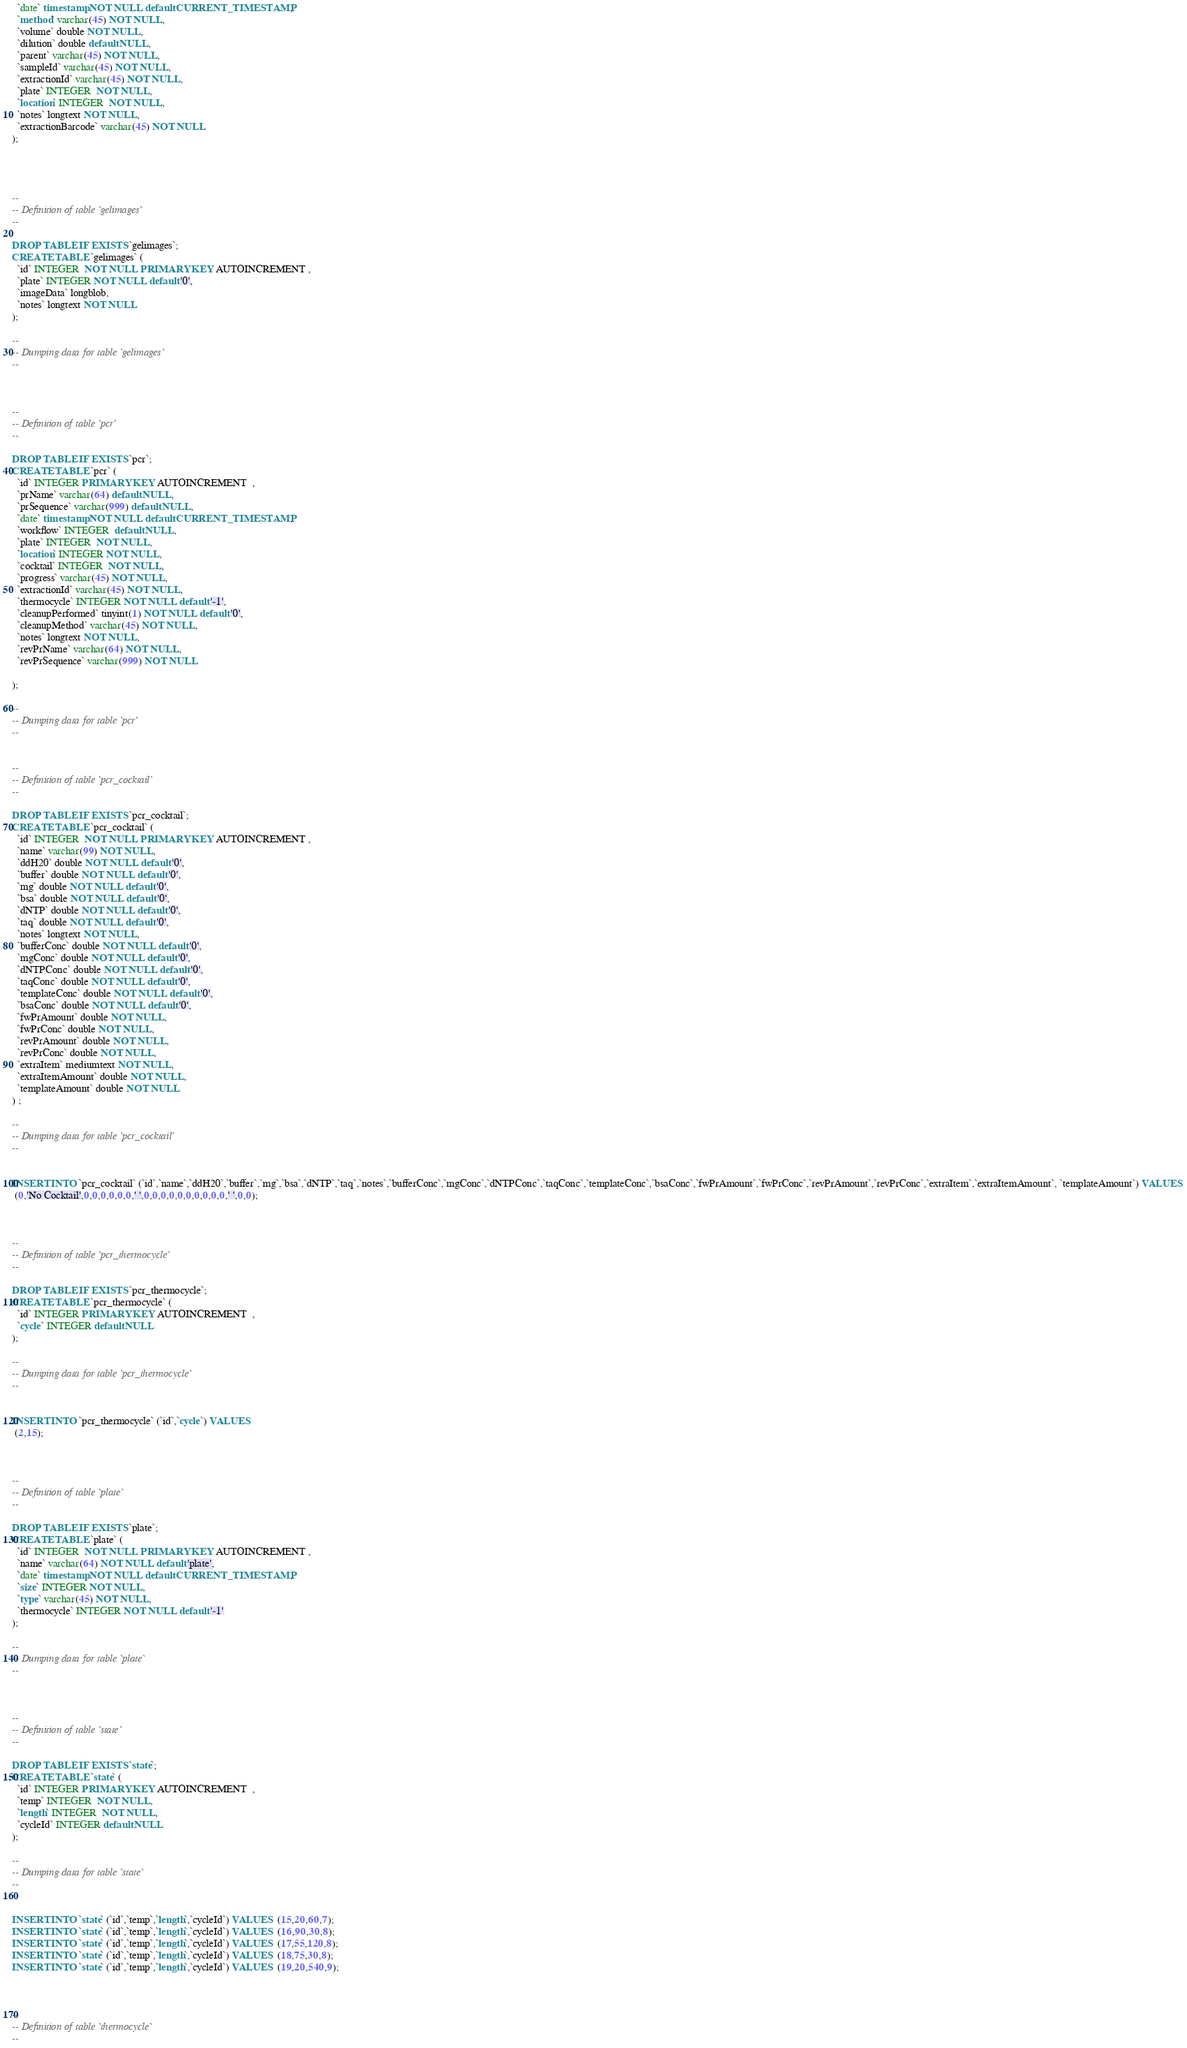Convert code to text. <code><loc_0><loc_0><loc_500><loc_500><_SQL_>  `date` timestamp NOT NULL default CURRENT_TIMESTAMP,
  `method` varchar(45) NOT NULL,
  `volume` double NOT NULL,
  `dilution` double default NULL,
  `parent` varchar(45) NOT NULL,
  `sampleId` varchar(45) NOT NULL,
  `extractionId` varchar(45) NOT NULL,
  `plate` INTEGER  NOT NULL,
  `location` INTEGER  NOT NULL,
  `notes` longtext NOT NULL,
  `extractionBarcode` varchar(45) NOT NULL
);




--
-- Definition of table `gelimages`
--

DROP TABLE IF EXISTS `gelimages`;
CREATE TABLE `gelimages` (
  `id` INTEGER  NOT NULL PRIMARY KEY AUTOINCREMENT ,
  `plate` INTEGER NOT NULL default '0',
  `imageData` longblob,
  `notes` longtext NOT NULL
);

--
-- Dumping data for table `gelimages`
--



--
-- Definition of table `pcr`
--

DROP TABLE IF EXISTS `pcr`;
CREATE TABLE `pcr` (
  `id` INTEGER PRIMARY KEY AUTOINCREMENT  ,
  `prName` varchar(64) default NULL,
  `prSequence` varchar(999) default NULL,
  `date` timestamp NOT NULL default CURRENT_TIMESTAMP,
  `workflow` INTEGER  default NULL,
  `plate` INTEGER  NOT NULL,
  `location` INTEGER NOT NULL,
  `cocktail` INTEGER  NOT NULL,
  `progress` varchar(45) NOT NULL,
  `extractionId` varchar(45) NOT NULL,
  `thermocycle` INTEGER NOT NULL default '-1',
  `cleanupPerformed` tinyint(1) NOT NULL default '0',
  `cleanupMethod` varchar(45) NOT NULL,
  `notes` longtext NOT NULL,
  `revPrName` varchar(64) NOT NULL,
  `revPrSequence` varchar(999) NOT NULL
  
);

--
-- Dumping data for table `pcr`
--


--
-- Definition of table `pcr_cocktail`
--

DROP TABLE IF EXISTS `pcr_cocktail`;
CREATE TABLE `pcr_cocktail` (
  `id` INTEGER  NOT NULL PRIMARY KEY AUTOINCREMENT ,
  `name` varchar(99) NOT NULL,
  `ddH20` double NOT NULL default '0',
  `buffer` double NOT NULL default '0',
  `mg` double NOT NULL default '0',
  `bsa` double NOT NULL default '0',
  `dNTP` double NOT NULL default '0',
  `taq` double NOT NULL default '0',
  `notes` longtext NOT NULL,
  `bufferConc` double NOT NULL default '0',
  `mgConc` double NOT NULL default '0',
  `dNTPConc` double NOT NULL default '0',
  `taqConc` double NOT NULL default '0',
  `templateConc` double NOT NULL default '0',
  `bsaConc` double NOT NULL default '0',
  `fwPrAmount` double NOT NULL,
  `fwPrConc` double NOT NULL,
  `revPrAmount` double NOT NULL,
  `revPrConc` double NOT NULL,
  `extraItem` mediumtext NOT NULL,
  `extraItemAmount` double NOT NULL,
  `templateAmount` double NOT NULL
) ;

--
-- Dumping data for table `pcr_cocktail`
--


INSERT INTO `pcr_cocktail` (`id`,`name`,`ddH20`,`buffer`,`mg`,`bsa`,`dNTP`,`taq`,`notes`,`bufferConc`,`mgConc`,`dNTPConc`,`taqConc`,`templateConc`,`bsaConc`,`fwPrAmount`,`fwPrConc`,`revPrAmount`,`revPrConc`,`extraItem`,`extraItemAmount`, `templateAmount`) VALUES 
 (0,'No Cocktail',0,0,0,0,0,0,' ',0,0,0,0,0,0,0,0,0,0,' ',0,0);



--
-- Definition of table `pcr_thermocycle`
--

DROP TABLE IF EXISTS `pcr_thermocycle`;
CREATE TABLE `pcr_thermocycle` (
  `id` INTEGER PRIMARY KEY AUTOINCREMENT  ,
  `cycle` INTEGER default NULL
);

--
-- Dumping data for table `pcr_thermocycle`
--


INSERT INTO `pcr_thermocycle` (`id`,`cycle`) VALUES 
 (2,15);



--
-- Definition of table `plate`
--

DROP TABLE IF EXISTS `plate`;
CREATE TABLE `plate` (
  `id` INTEGER  NOT NULL PRIMARY KEY AUTOINCREMENT ,
  `name` varchar(64) NOT NULL default 'plate',
  `date` timestamp NOT NULL default CURRENT_TIMESTAMP,
  `size` INTEGER NOT NULL,
  `type` varchar(45) NOT NULL,
  `thermocycle` INTEGER NOT NULL default '-1'
);

--
-- Dumping data for table `plate`
--



--
-- Definition of table `state`
--

DROP TABLE IF EXISTS `state`;
CREATE TABLE `state` (
  `id` INTEGER PRIMARY KEY AUTOINCREMENT  ,
  `temp` INTEGER  NOT NULL,
  `length` INTEGER  NOT NULL,
  `cycleId` INTEGER default NULL
);

--
-- Dumping data for table `state`
--


INSERT INTO `state` (`id`,`temp`,`length`,`cycleId`) VALUES  (15,20,60,7);
INSERT INTO `state` (`id`,`temp`,`length`,`cycleId`) VALUES  (16,90,30,8);
INSERT INTO `state` (`id`,`temp`,`length`,`cycleId`) VALUES  (17,55,120,8);
INSERT INTO `state` (`id`,`temp`,`length`,`cycleId`) VALUES  (18,75,30,8);
INSERT INTO `state` (`id`,`temp`,`length`,`cycleId`) VALUES  (19,20,540,9);



--
-- Definition of table `thermocycle`
--
</code> 